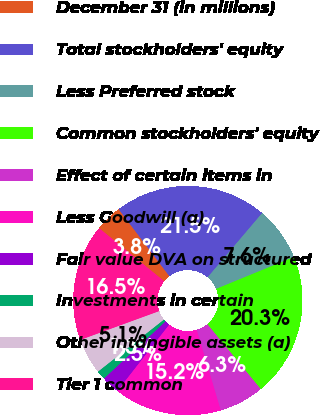Convert chart. <chart><loc_0><loc_0><loc_500><loc_500><pie_chart><fcel>December 31 (in millions)<fcel>Total stockholders' equity<fcel>Less Preferred stock<fcel>Common stockholders' equity<fcel>Effect of certain items in<fcel>Less Goodwill (a)<fcel>Fair value DVA on structured<fcel>Investments in certain<fcel>Other intangible assets (a)<fcel>Tier 1 common<nl><fcel>3.8%<fcel>21.52%<fcel>7.59%<fcel>20.25%<fcel>6.33%<fcel>15.19%<fcel>2.53%<fcel>1.27%<fcel>5.06%<fcel>16.46%<nl></chart> 